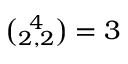<formula> <loc_0><loc_0><loc_500><loc_500>{ \binom { 4 } { 2 , 2 } } = 3</formula> 